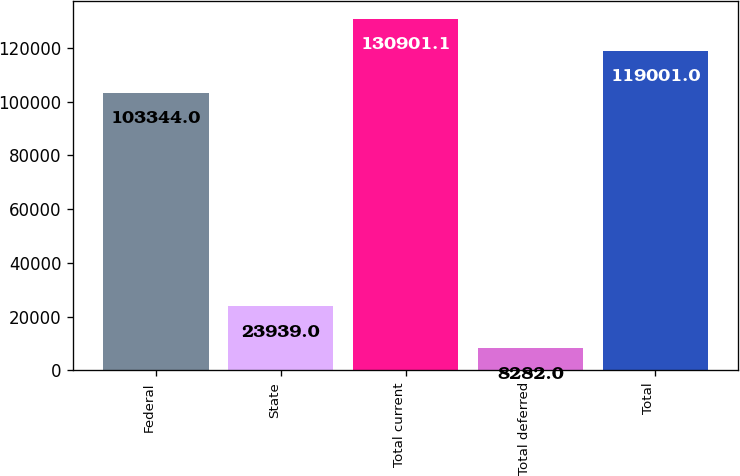Convert chart to OTSL. <chart><loc_0><loc_0><loc_500><loc_500><bar_chart><fcel>Federal<fcel>State<fcel>Total current<fcel>Total deferred<fcel>Total<nl><fcel>103344<fcel>23939<fcel>130901<fcel>8282<fcel>119001<nl></chart> 